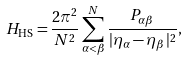<formula> <loc_0><loc_0><loc_500><loc_500>H _ { \text {HS} } = \frac { 2 \pi ^ { 2 } } { N ^ { 2 } } \sum ^ { N } _ { \alpha < \beta } \frac { P _ { \alpha \beta } } { | \eta _ { \alpha } - \eta _ { \beta } | ^ { 2 } } ,</formula> 